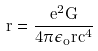Convert formula to latex. <formula><loc_0><loc_0><loc_500><loc_500>r = \frac { e ^ { 2 } G } { 4 \pi \epsilon _ { o } r c ^ { 4 } }</formula> 